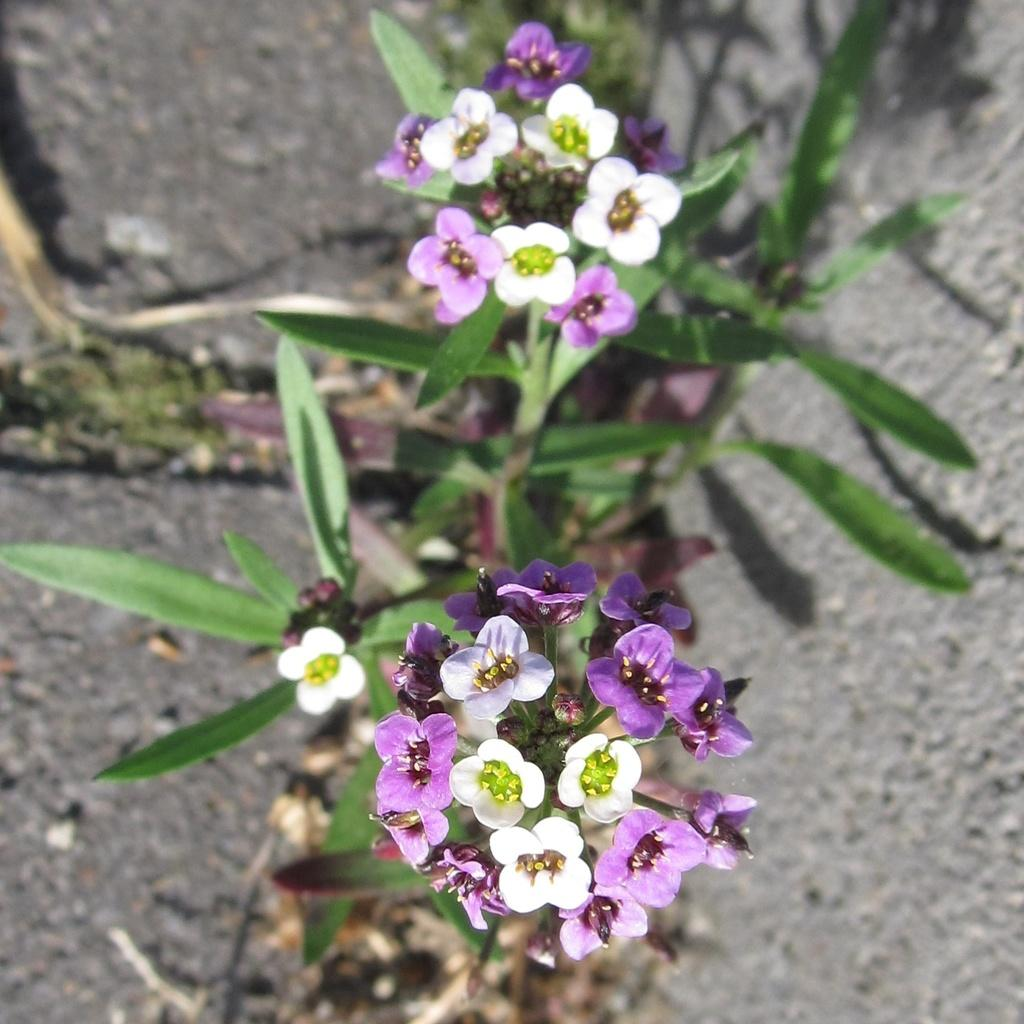What colors are the flowers in the image? The flowers in the image are white and violet. What are the flowers attached to? The flowers are on plants. What color are the leaves of the plants? The leaves of the plants are green. How would you describe the background of the image? The background of the image is blurred. What type of coat is the airplane wearing in the image? There is no airplane present in the image, and therefore no coat can be associated with it. 